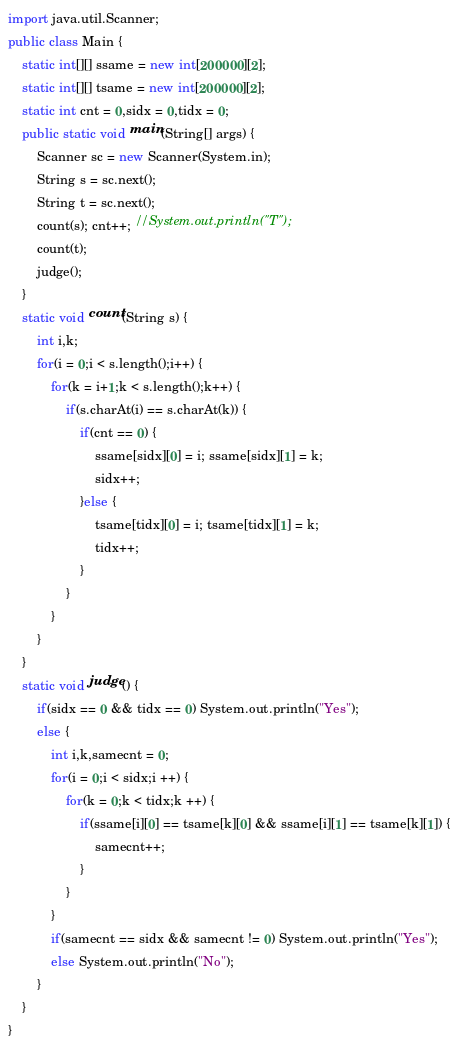<code> <loc_0><loc_0><loc_500><loc_500><_Java_>import java.util.Scanner;
public class Main {
	static int[][] ssame = new int[200000][2];
	static int[][] tsame = new int[200000][2];
	static int cnt = 0,sidx = 0,tidx = 0;
	public static void main(String[] args) {
		Scanner sc = new Scanner(System.in);
		String s = sc.next();
		String t = sc.next();
		count(s); cnt++; //System.out.println("T");
		count(t);
		judge();
	}
	static void count(String s) {
		int i,k;
		for(i = 0;i < s.length();i++) {
			for(k = i+1;k < s.length();k++) {
				if(s.charAt(i) == s.charAt(k)) {
					if(cnt == 0) {
						ssame[sidx][0] = i; ssame[sidx][1] = k;
						sidx++;
					}else {
						tsame[tidx][0] = i; tsame[tidx][1] = k;
						tidx++;
					}
				}
			}
		}
	}
	static void judge() {
		if(sidx == 0 && tidx == 0) System.out.println("Yes");
		else {
			int i,k,samecnt = 0;
			for(i = 0;i < sidx;i ++) {
				for(k = 0;k < tidx;k ++) {
					if(ssame[i][0] == tsame[k][0] && ssame[i][1] == tsame[k][1]) {
						samecnt++;
					}
				}
			}
			if(samecnt == sidx && samecnt != 0) System.out.println("Yes");
			else System.out.println("No");
		}
	}
}</code> 